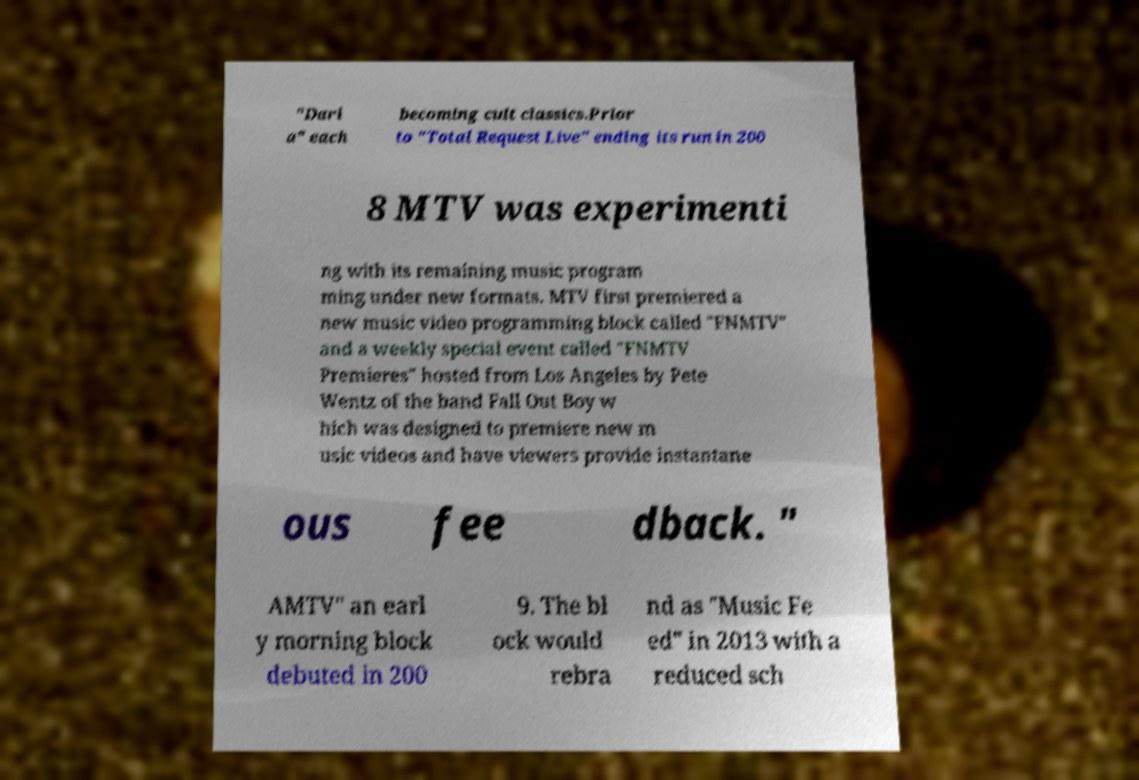Please identify and transcribe the text found in this image. "Dari a" each becoming cult classics.Prior to "Total Request Live" ending its run in 200 8 MTV was experimenti ng with its remaining music program ming under new formats. MTV first premiered a new music video programming block called "FNMTV" and a weekly special event called "FNMTV Premieres" hosted from Los Angeles by Pete Wentz of the band Fall Out Boy w hich was designed to premiere new m usic videos and have viewers provide instantane ous fee dback. " AMTV" an earl y morning block debuted in 200 9. The bl ock would rebra nd as "Music Fe ed" in 2013 with a reduced sch 